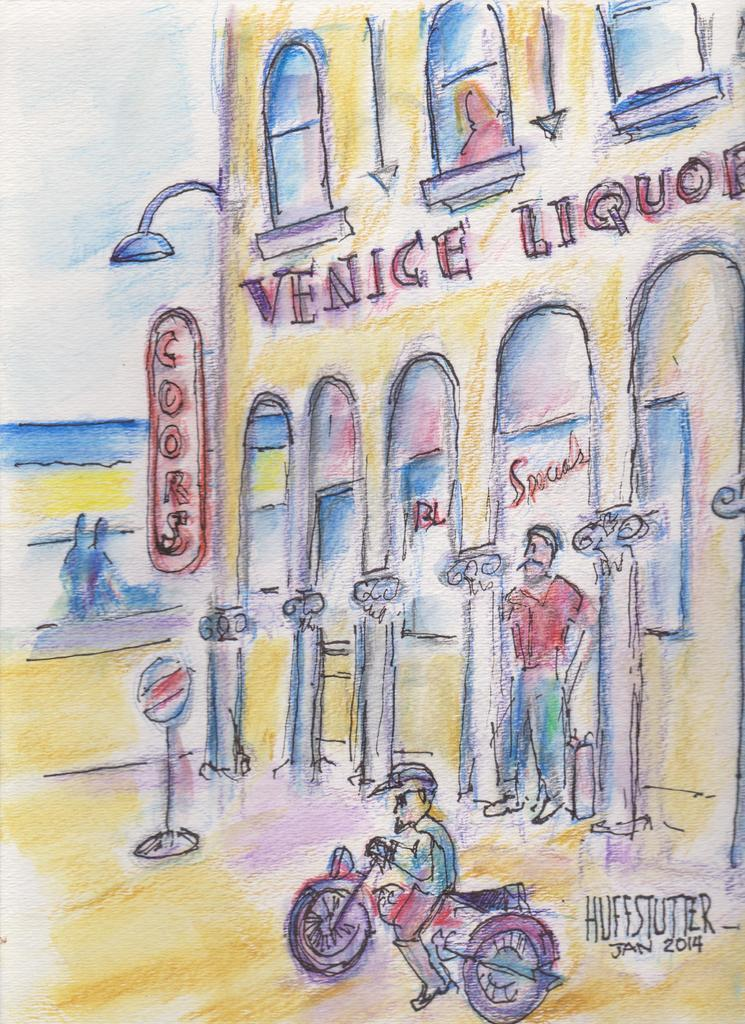What type of paintings are present in the image? There are paintings of a house, windows, a light pole, boards, a person, and a bike in the image. Are there any people depicted in the paintings? Yes, there are paintings of a person and three people in the image. What other elements can be seen in the paintings? There is text present in the paintings. What is visible in the background of the image? The sky is visible in the image. What degree does the writer in the image have? There is no writer present in the image, as it only contains paintings. What type of power source is depicted in the paintings? There is no power source depicted in the paintings; they primarily feature a house, windows, a light pole, boards, a person, and a bike. 